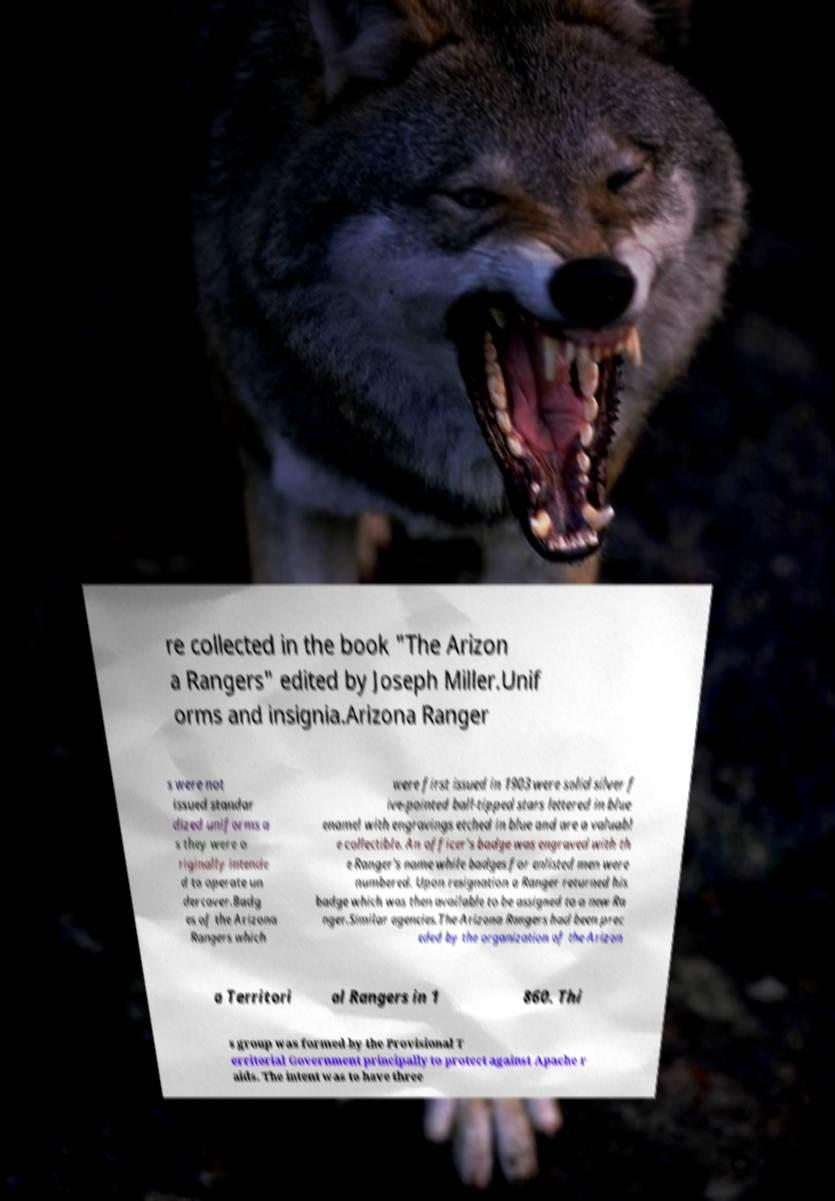Please identify and transcribe the text found in this image. re collected in the book "The Arizon a Rangers" edited by Joseph Miller.Unif orms and insignia.Arizona Ranger s were not issued standar dized uniforms a s they were o riginally intende d to operate un dercover.Badg es of the Arizona Rangers which were first issued in 1903 were solid silver f ive-pointed ball-tipped stars lettered in blue enamel with engravings etched in blue and are a valuabl e collectible. An officer's badge was engraved with th e Ranger's name while badges for enlisted men were numbered. Upon resignation a Ranger returned his badge which was then available to be assigned to a new Ra nger.Similar agencies.The Arizona Rangers had been prec eded by the organization of the Arizon a Territori al Rangers in 1 860. Thi s group was formed by the Provisional T erritorial Government principally to protect against Apache r aids. The intent was to have three 